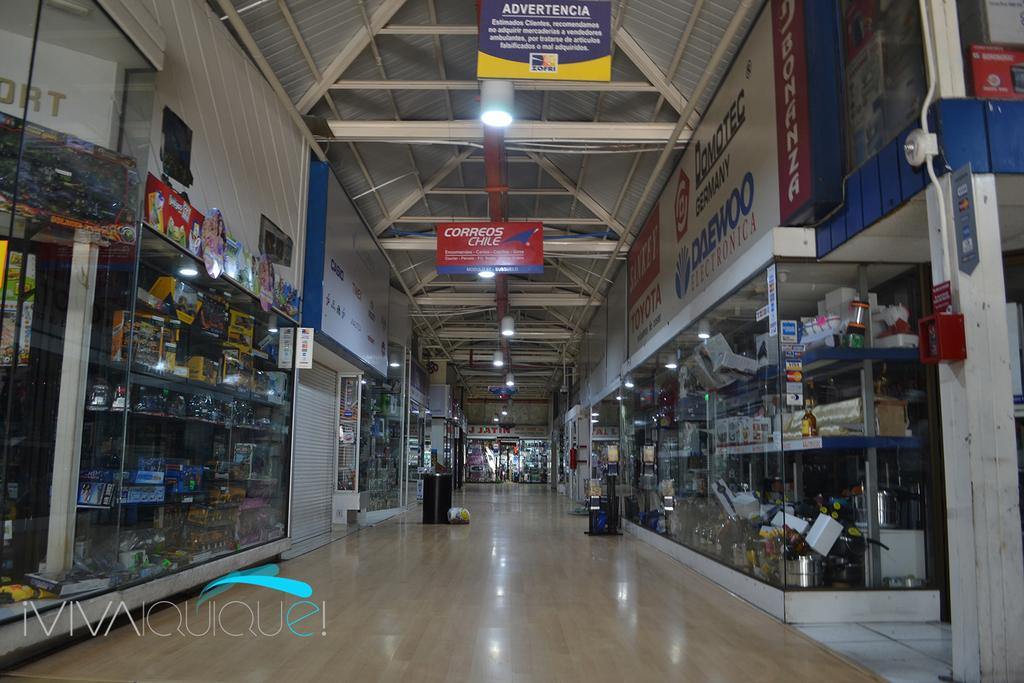What is the large white warning in the blue sign above?
Keep it short and to the point. Unanswerable. What country is named on the red sign hanging in the center?
Provide a short and direct response. Chile. 